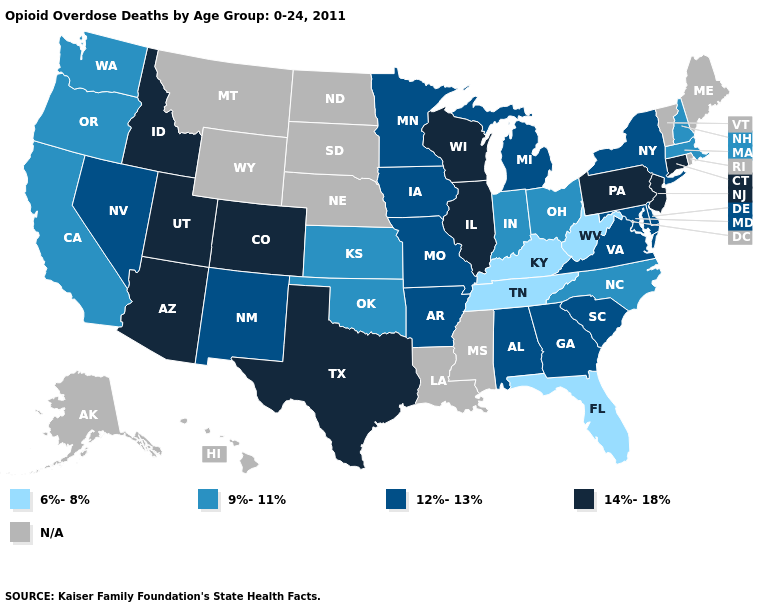Among the states that border Texas , which have the lowest value?
Give a very brief answer. Oklahoma. Name the states that have a value in the range 9%-11%?
Answer briefly. California, Indiana, Kansas, Massachusetts, New Hampshire, North Carolina, Ohio, Oklahoma, Oregon, Washington. What is the value of Florida?
Be succinct. 6%-8%. What is the value of Oregon?
Quick response, please. 9%-11%. Does the first symbol in the legend represent the smallest category?
Short answer required. Yes. What is the value of Washington?
Answer briefly. 9%-11%. Name the states that have a value in the range 14%-18%?
Be succinct. Arizona, Colorado, Connecticut, Idaho, Illinois, New Jersey, Pennsylvania, Texas, Utah, Wisconsin. What is the value of Florida?
Give a very brief answer. 6%-8%. What is the highest value in the Northeast ?
Short answer required. 14%-18%. Name the states that have a value in the range 6%-8%?
Keep it brief. Florida, Kentucky, Tennessee, West Virginia. What is the lowest value in the MidWest?
Give a very brief answer. 9%-11%. Which states have the lowest value in the USA?
Answer briefly. Florida, Kentucky, Tennessee, West Virginia. What is the value of Nebraska?
Concise answer only. N/A. 